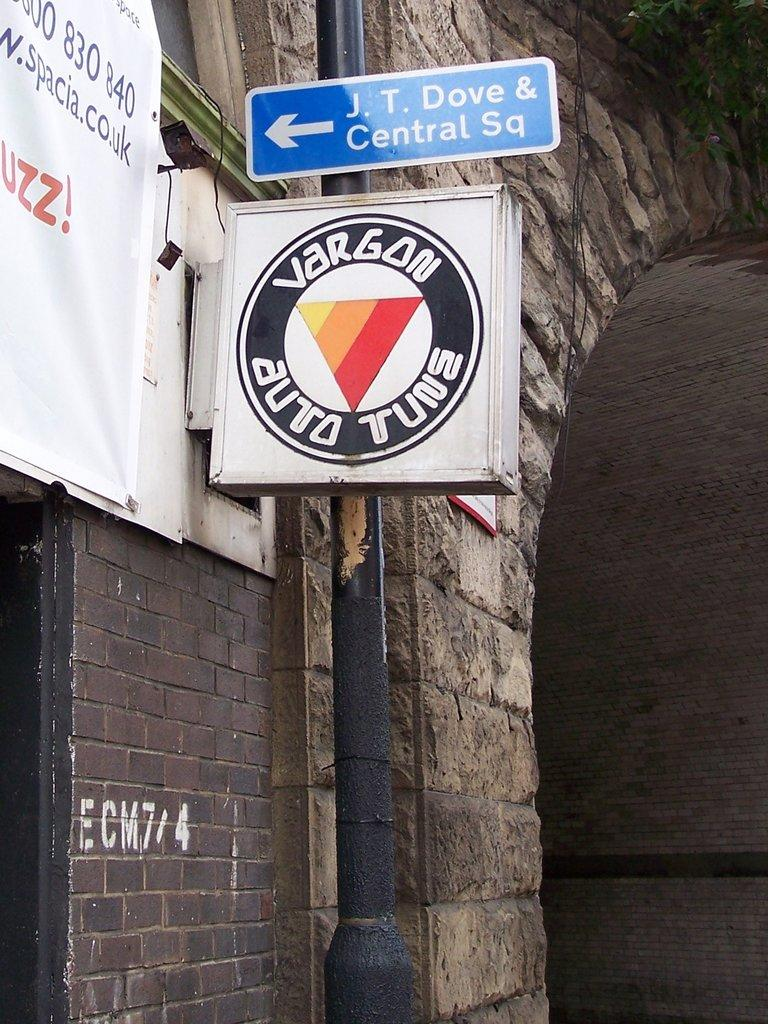What is the main structure in the image? There is a pole in the image with boards attached to it. What is featured on the boards? There is a logo and writing on the boards. What else can be seen in the image? There is a wall in the image with objects attached to it. What type of stew is being served in the hall during the summer in the image? There is no reference to a hall, summer, or stew in the image. The image features a pole with boards attached to it, along with a wall with objects attached to it. 